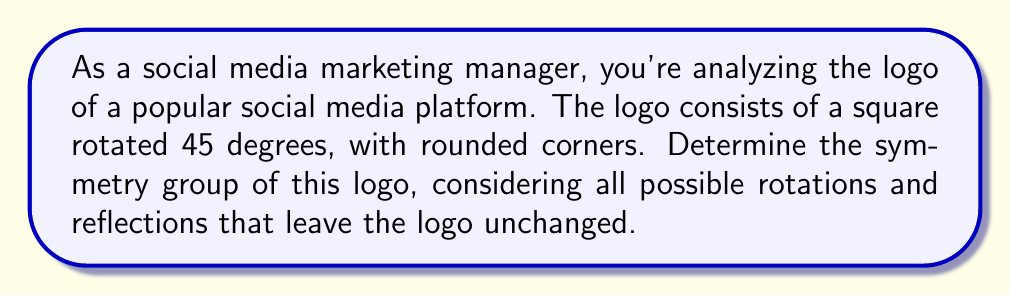Teach me how to tackle this problem. Let's approach this step-by-step:

1) First, we need to identify all the symmetries of the logo:

   a) Rotational symmetries:
      - 0° rotation (identity)
      - 90° rotation
      - 180° rotation
      - 270° rotation

   b) Reflection symmetries:
      - Reflection across the vertical axis
      - Reflection across the horizontal axis
      - Reflection across the diagonal (top-left to bottom-right)
      - Reflection across the other diagonal (top-right to bottom-left)

2) These symmetries form a group under composition. Let's identify this group:

   - It has 8 elements in total (4 rotations and 4 reflections)
   - It contains rotations of order 4 (90° rotations)
   - It contains reflections

3) The group of symmetries of a square is known as the dihedral group of order 8, denoted as $D_4$ or $D_8$ (depending on the notation system).

4) The group operation table for $D_4$ can be represented as:

   $$
   \begin{array}{c|cccc|cccc}
    & e & r & r^2 & r^3 & s & sr & sr^2 & sr^3 \\
   \hline
   e & e & r & r^2 & r^3 & s & sr & sr^2 & sr^3 \\
   r & r & r^2 & r^3 & e & sr & sr^2 & sr^3 & s \\
   r^2 & r^2 & r^3 & e & r & sr^2 & sr^3 & s & sr \\
   r^3 & r^3 & e & r & r^2 & sr^3 & s & sr & sr^2 \\
   \hline
   s & s & sr^3 & sr^2 & sr & e & r^3 & r^2 & r \\
   sr & sr & s & sr^3 & sr^2 & r & e & r^3 & r^2 \\
   sr^2 & sr^2 & sr & s & sr^3 & r^2 & r & e & r^3 \\
   sr^3 & sr^3 & sr^2 & sr & s & r^3 & r^2 & r & e
   \end{array}
   $$

   Where $e$ is the identity, $r$ is a 90° rotation, and $s$ is a reflection.

5) The group $D_4$ is non-abelian, as rotation followed by reflection is not always the same as reflection followed by rotation.

Therefore, the symmetry group of the logo is the dihedral group $D_4$.
Answer: $D_4$ 